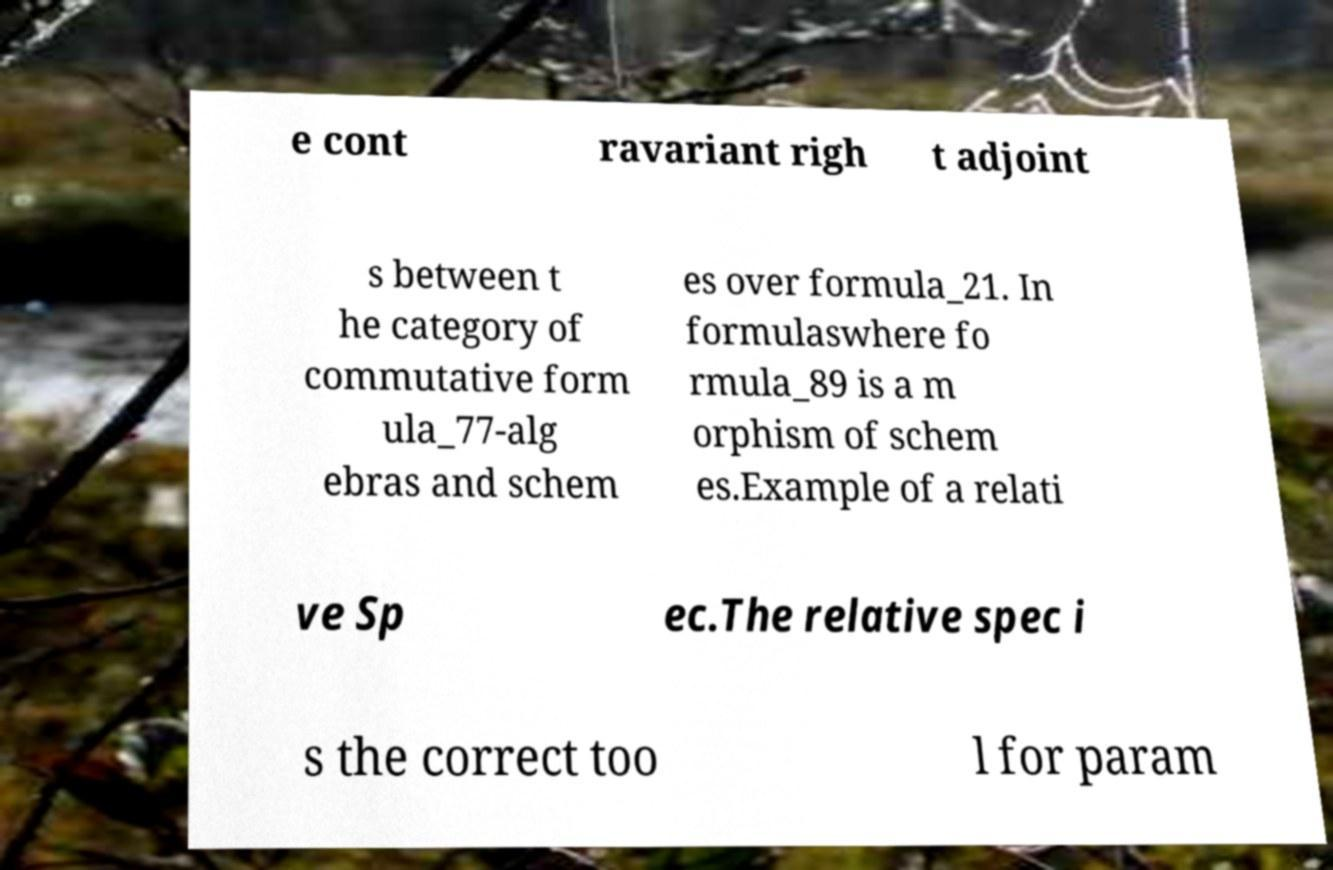Can you read and provide the text displayed in the image?This photo seems to have some interesting text. Can you extract and type it out for me? e cont ravariant righ t adjoint s between t he category of commutative form ula_77-alg ebras and schem es over formula_21. In formulaswhere fo rmula_89 is a m orphism of schem es.Example of a relati ve Sp ec.The relative spec i s the correct too l for param 